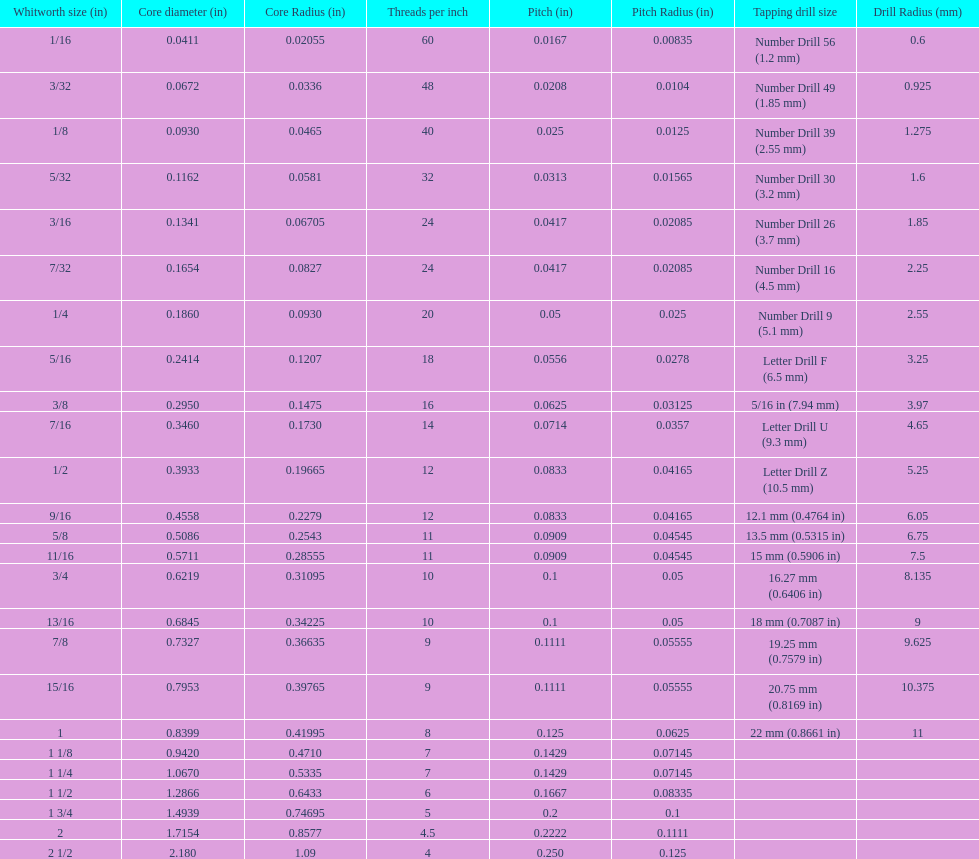What whitworth measurement shares the same threads per inch as 3/16? 7/32. 